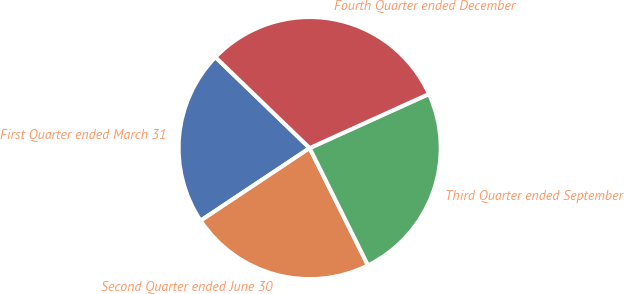Convert chart. <chart><loc_0><loc_0><loc_500><loc_500><pie_chart><fcel>First Quarter ended March 31<fcel>Second Quarter ended June 30<fcel>Third Quarter ended September<fcel>Fourth Quarter ended December<nl><fcel>21.56%<fcel>23.0%<fcel>24.43%<fcel>31.01%<nl></chart> 